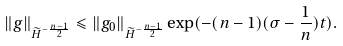<formula> <loc_0><loc_0><loc_500><loc_500>\| g \| _ { \widetilde { H } ^ { - \frac { n - 1 } 2 } } \leqslant \| g _ { 0 } \| _ { \widetilde { H } ^ { - \frac { n - 1 } 2 } } \exp ( - ( n - 1 ) ( \sigma - \frac { 1 } { n } ) t ) .</formula> 